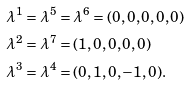<formula> <loc_0><loc_0><loc_500><loc_500>\lambda ^ { 1 } & = \lambda ^ { 5 } = \lambda ^ { 6 } = ( 0 , 0 , 0 , 0 , 0 ) \\ \lambda ^ { 2 } & = \lambda ^ { 7 } = ( 1 , 0 , 0 , 0 , 0 ) \\ \lambda ^ { 3 } & = \lambda ^ { 4 } = ( 0 , 1 , 0 , - 1 , 0 ) .</formula> 